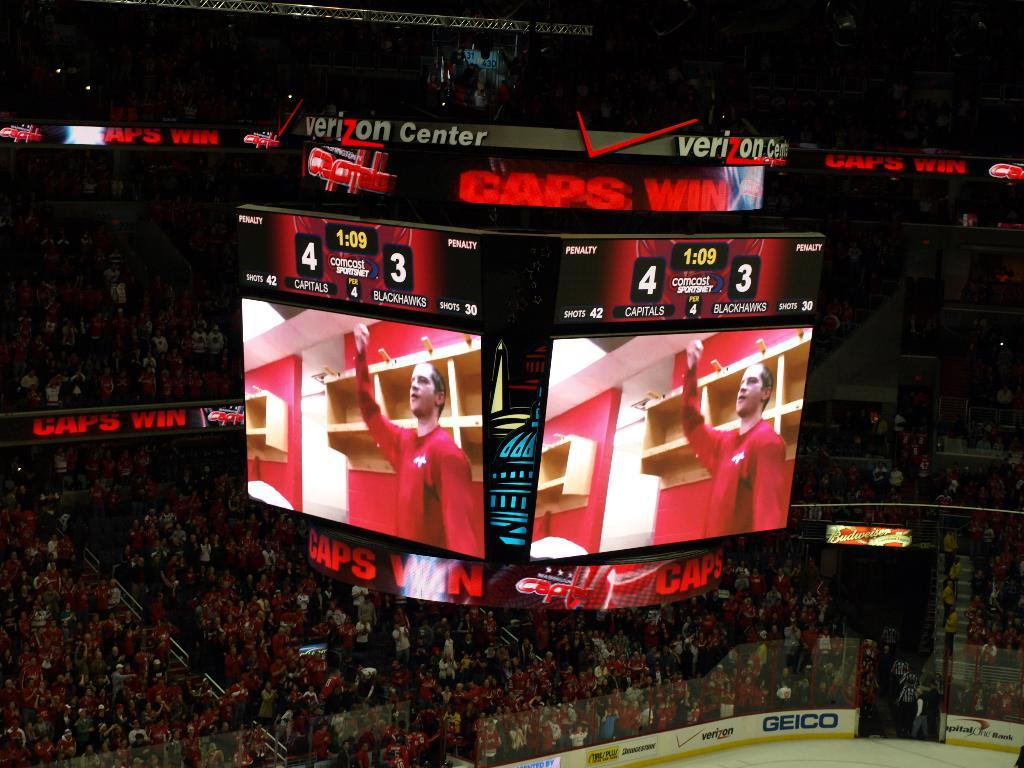Provide a one-sentence caption for the provided image. Hockey game jumbo tron screen that says score 4-3 with the words Verizon Center on top. 